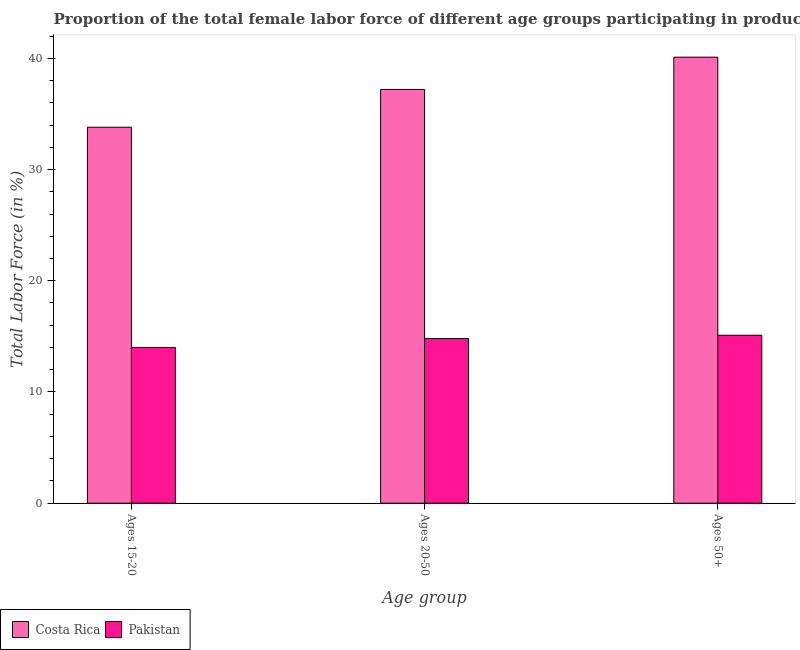Are the number of bars on each tick of the X-axis equal?
Make the answer very short. Yes. How many bars are there on the 2nd tick from the right?
Offer a terse response. 2. What is the label of the 1st group of bars from the left?
Give a very brief answer. Ages 15-20. What is the percentage of female labor force above age 50 in Pakistan?
Give a very brief answer. 15.1. Across all countries, what is the maximum percentage of female labor force within the age group 15-20?
Make the answer very short. 33.8. Across all countries, what is the minimum percentage of female labor force within the age group 15-20?
Provide a succinct answer. 14. In which country was the percentage of female labor force within the age group 15-20 maximum?
Offer a terse response. Costa Rica. What is the total percentage of female labor force within the age group 20-50 in the graph?
Offer a very short reply. 52. What is the difference between the percentage of female labor force within the age group 20-50 in Pakistan and that in Costa Rica?
Give a very brief answer. -22.4. What is the difference between the percentage of female labor force above age 50 in Pakistan and the percentage of female labor force within the age group 20-50 in Costa Rica?
Your answer should be very brief. -22.1. What is the average percentage of female labor force within the age group 20-50 per country?
Ensure brevity in your answer.  26. What is the difference between the percentage of female labor force within the age group 20-50 and percentage of female labor force within the age group 15-20 in Costa Rica?
Your answer should be compact. 3.4. What is the ratio of the percentage of female labor force above age 50 in Costa Rica to that in Pakistan?
Keep it short and to the point. 2.66. Is the percentage of female labor force within the age group 15-20 in Pakistan less than that in Costa Rica?
Make the answer very short. Yes. Is the difference between the percentage of female labor force above age 50 in Costa Rica and Pakistan greater than the difference between the percentage of female labor force within the age group 20-50 in Costa Rica and Pakistan?
Your response must be concise. Yes. What is the difference between the highest and the second highest percentage of female labor force within the age group 20-50?
Offer a very short reply. 22.4. What is the difference between the highest and the lowest percentage of female labor force within the age group 20-50?
Keep it short and to the point. 22.4. In how many countries, is the percentage of female labor force within the age group 15-20 greater than the average percentage of female labor force within the age group 15-20 taken over all countries?
Provide a succinct answer. 1. Is the sum of the percentage of female labor force within the age group 20-50 in Pakistan and Costa Rica greater than the maximum percentage of female labor force within the age group 15-20 across all countries?
Offer a terse response. Yes. What does the 1st bar from the right in Ages 15-20 represents?
Keep it short and to the point. Pakistan. Are all the bars in the graph horizontal?
Provide a succinct answer. No. What is the difference between two consecutive major ticks on the Y-axis?
Offer a terse response. 10. Are the values on the major ticks of Y-axis written in scientific E-notation?
Your response must be concise. No. Does the graph contain any zero values?
Your response must be concise. No. How many legend labels are there?
Your answer should be very brief. 2. What is the title of the graph?
Keep it short and to the point. Proportion of the total female labor force of different age groups participating in production in 1997. Does "East Asia (all income levels)" appear as one of the legend labels in the graph?
Your response must be concise. No. What is the label or title of the X-axis?
Your response must be concise. Age group. What is the Total Labor Force (in %) of Costa Rica in Ages 15-20?
Make the answer very short. 33.8. What is the Total Labor Force (in %) in Costa Rica in Ages 20-50?
Offer a very short reply. 37.2. What is the Total Labor Force (in %) in Pakistan in Ages 20-50?
Provide a short and direct response. 14.8. What is the Total Labor Force (in %) of Costa Rica in Ages 50+?
Your response must be concise. 40.1. What is the Total Labor Force (in %) of Pakistan in Ages 50+?
Your answer should be very brief. 15.1. Across all Age group, what is the maximum Total Labor Force (in %) in Costa Rica?
Your response must be concise. 40.1. Across all Age group, what is the maximum Total Labor Force (in %) of Pakistan?
Offer a terse response. 15.1. Across all Age group, what is the minimum Total Labor Force (in %) in Costa Rica?
Give a very brief answer. 33.8. Across all Age group, what is the minimum Total Labor Force (in %) in Pakistan?
Keep it short and to the point. 14. What is the total Total Labor Force (in %) in Costa Rica in the graph?
Give a very brief answer. 111.1. What is the total Total Labor Force (in %) in Pakistan in the graph?
Ensure brevity in your answer.  43.9. What is the difference between the Total Labor Force (in %) of Pakistan in Ages 15-20 and that in Ages 50+?
Your answer should be very brief. -1.1. What is the difference between the Total Labor Force (in %) in Costa Rica in Ages 20-50 and that in Ages 50+?
Make the answer very short. -2.9. What is the difference between the Total Labor Force (in %) in Costa Rica in Ages 15-20 and the Total Labor Force (in %) in Pakistan in Ages 50+?
Provide a short and direct response. 18.7. What is the difference between the Total Labor Force (in %) of Costa Rica in Ages 20-50 and the Total Labor Force (in %) of Pakistan in Ages 50+?
Ensure brevity in your answer.  22.1. What is the average Total Labor Force (in %) of Costa Rica per Age group?
Your response must be concise. 37.03. What is the average Total Labor Force (in %) in Pakistan per Age group?
Provide a succinct answer. 14.63. What is the difference between the Total Labor Force (in %) of Costa Rica and Total Labor Force (in %) of Pakistan in Ages 15-20?
Offer a very short reply. 19.8. What is the difference between the Total Labor Force (in %) of Costa Rica and Total Labor Force (in %) of Pakistan in Ages 20-50?
Keep it short and to the point. 22.4. What is the ratio of the Total Labor Force (in %) of Costa Rica in Ages 15-20 to that in Ages 20-50?
Your response must be concise. 0.91. What is the ratio of the Total Labor Force (in %) in Pakistan in Ages 15-20 to that in Ages 20-50?
Give a very brief answer. 0.95. What is the ratio of the Total Labor Force (in %) in Costa Rica in Ages 15-20 to that in Ages 50+?
Your response must be concise. 0.84. What is the ratio of the Total Labor Force (in %) in Pakistan in Ages 15-20 to that in Ages 50+?
Your response must be concise. 0.93. What is the ratio of the Total Labor Force (in %) in Costa Rica in Ages 20-50 to that in Ages 50+?
Ensure brevity in your answer.  0.93. What is the ratio of the Total Labor Force (in %) of Pakistan in Ages 20-50 to that in Ages 50+?
Your answer should be compact. 0.98. What is the difference between the highest and the lowest Total Labor Force (in %) of Pakistan?
Your response must be concise. 1.1. 